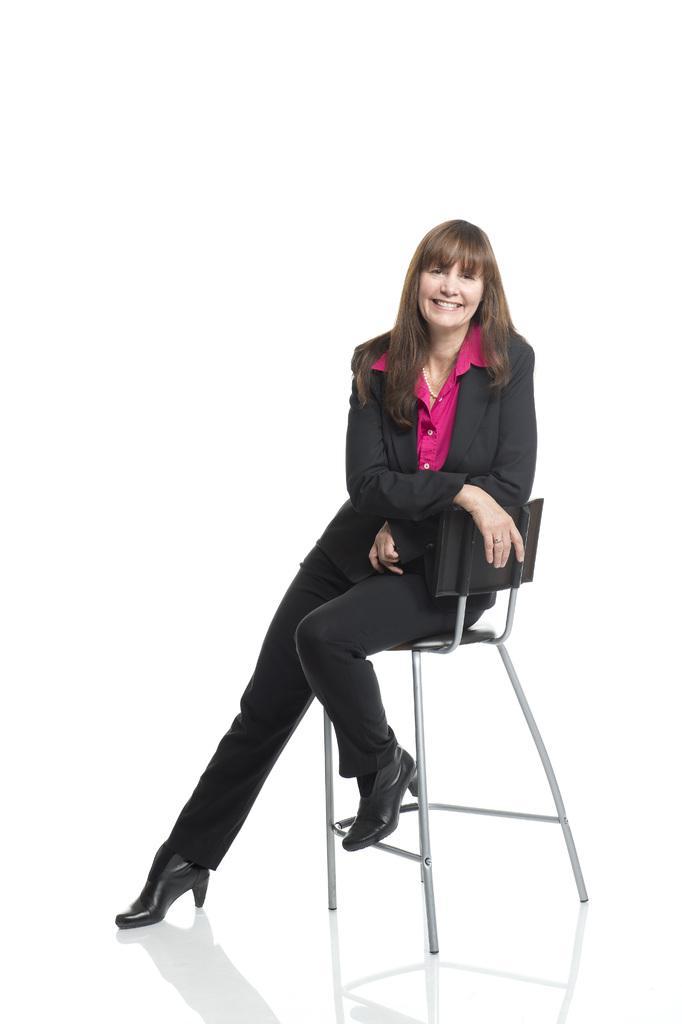Could you give a brief overview of what you see in this image? In this picture we can see a woman sitting on a chair, she is smiling and in the background we can see it is white color. 